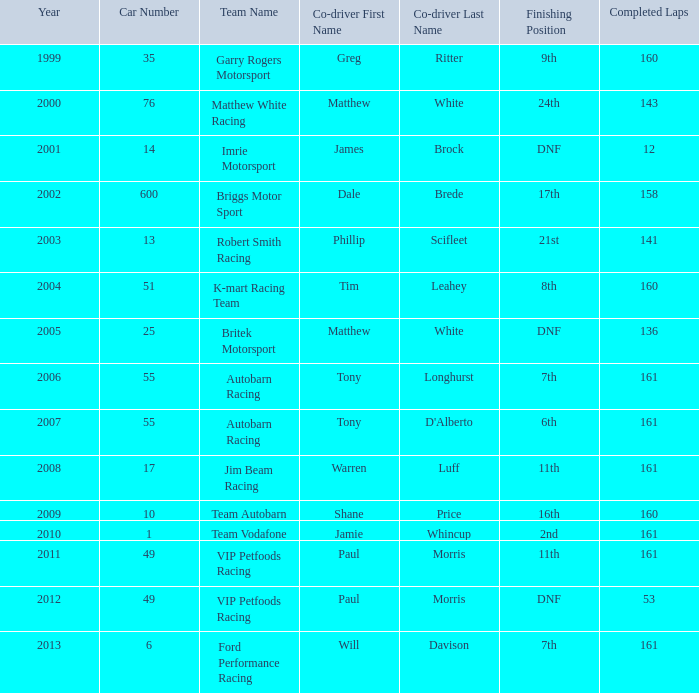Who was the co-driver for the team with more than 160 laps and the number 6 after 2010? Will Davison. 